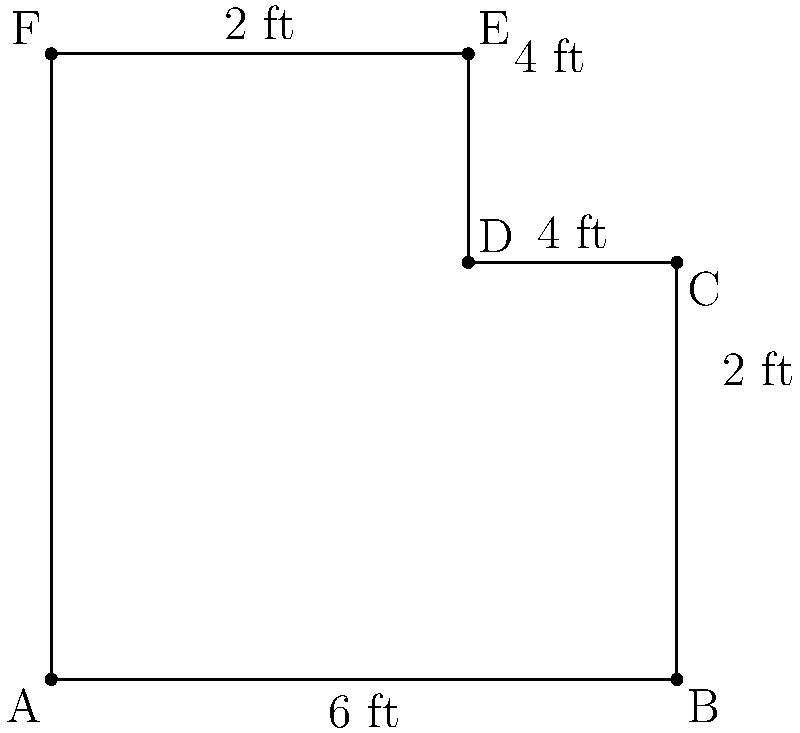You're designing a custom L-shaped trophy display case for your office to showcase soccer memorabilia from your professional playing days. The case has the dimensions shown in the diagram. What is the perimeter of this display case? To find the perimeter of the L-shaped display case, we need to sum up all the outer edges:

1. Start from point A and move clockwise:
   - AB = 6 ft
   - BC = 2 ft
   - CD = 2 ft
   - DE = 2 ft
   - EF = 4 ft
   - FA = 6 ft

2. Sum up all these lengths:
   $$ \text{Perimeter} = 6 + 2 + 2 + 2 + 4 + 6 = 22 \text{ ft} $$

Therefore, the perimeter of the L-shaped trophy display case is 22 feet.
Answer: 22 ft 